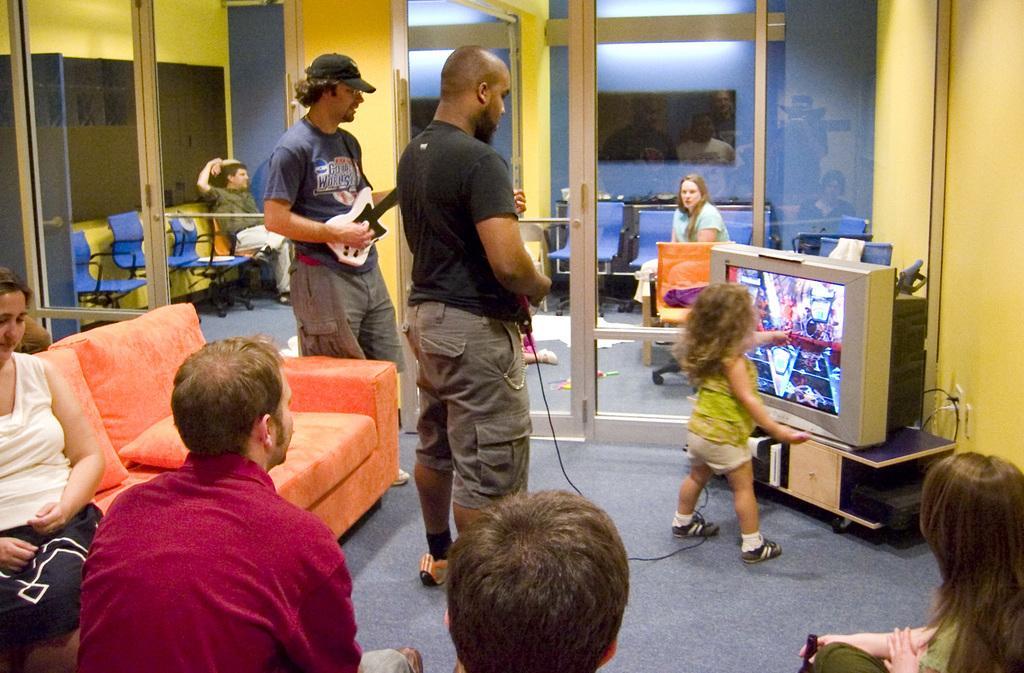Describe this image in one or two sentences. In the image there is a baby and a man standing in front of tv and playing video game in it and behind him there is a man in grey t-shirt playing guitar, there are few people sitting on sofa in the front, in the back there is glass wall with two persons sitting behind it on chairs and lights above on the ceiling. 